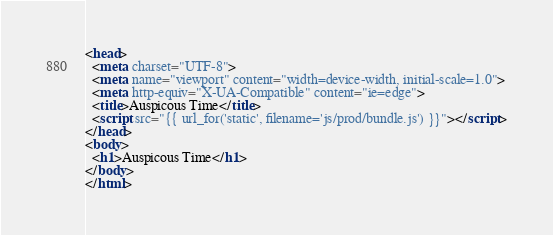Convert code to text. <code><loc_0><loc_0><loc_500><loc_500><_HTML_><head>
  <meta charset="UTF-8">
  <meta name="viewport" content="width=device-width, initial-scale=1.0">
  <meta http-equiv="X-UA-Compatible" content="ie=edge">
  <title>Auspicous Time</title>
  <script src="{{ url_for('static', filename='js/prod/bundle.js') }}"></script>
</head>
<body>
  <h1>Auspicous Time</h1>
</body>
</html></code> 